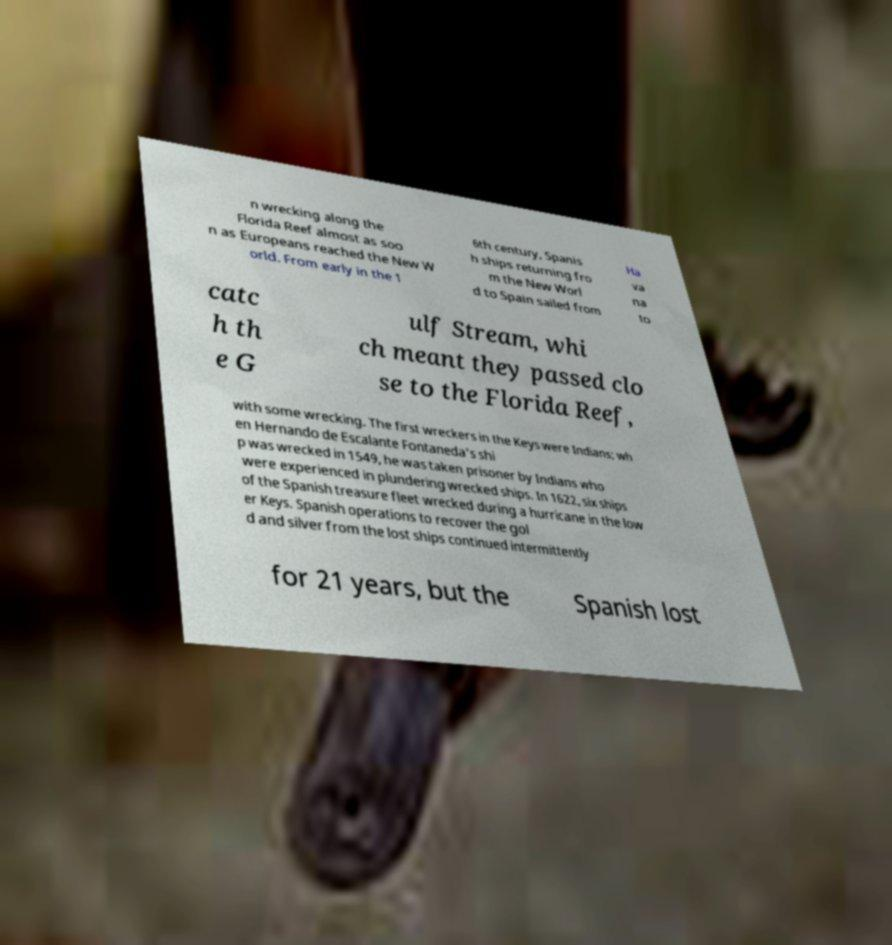Please read and relay the text visible in this image. What does it say? n wrecking along the Florida Reef almost as soo n as Europeans reached the New W orld. From early in the 1 6th century, Spanis h ships returning fro m the New Worl d to Spain sailed from Ha va na to catc h th e G ulf Stream, whi ch meant they passed clo se to the Florida Reef, with some wrecking. The first wreckers in the Keys were Indians; wh en Hernando de Escalante Fontaneda's shi p was wrecked in 1549, he was taken prisoner by Indians who were experienced in plundering wrecked ships. In 1622, six ships of the Spanish treasure fleet wrecked during a hurricane in the low er Keys. Spanish operations to recover the gol d and silver from the lost ships continued intermittently for 21 years, but the Spanish lost 